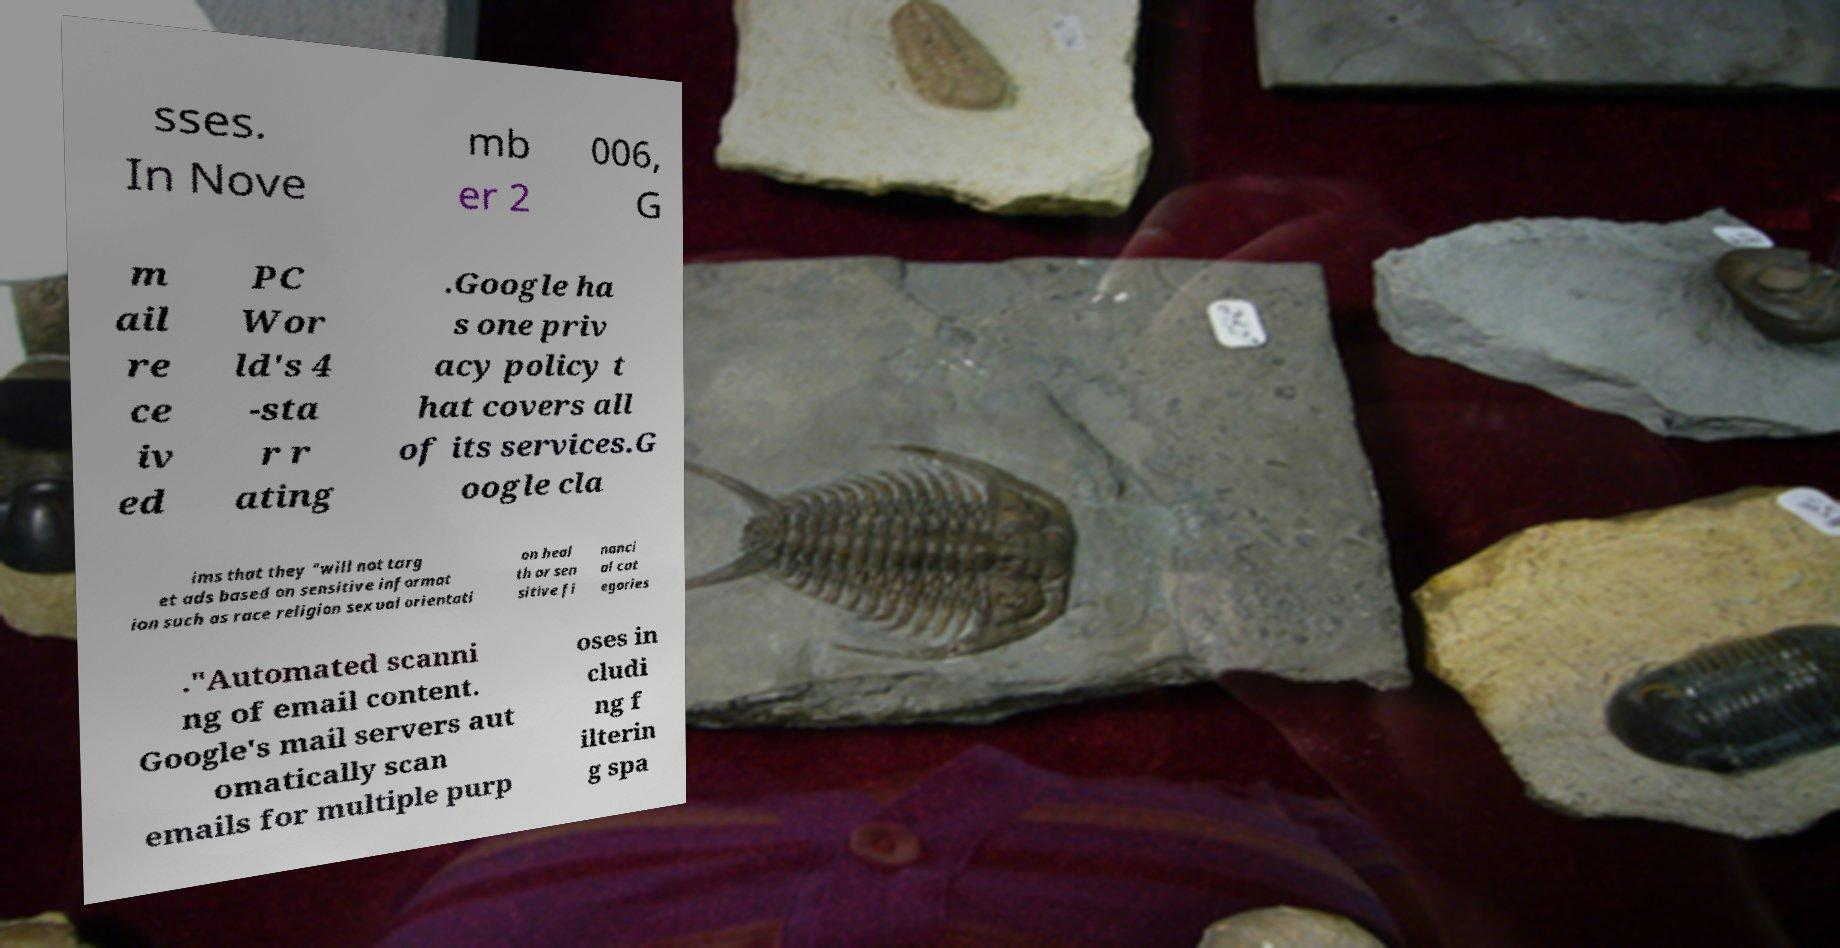Can you accurately transcribe the text from the provided image for me? sses. In Nove mb er 2 006, G m ail re ce iv ed PC Wor ld's 4 -sta r r ating .Google ha s one priv acy policy t hat covers all of its services.G oogle cla ims that they "will not targ et ads based on sensitive informat ion such as race religion sexual orientati on heal th or sen sitive fi nanci al cat egories ."Automated scanni ng of email content. Google's mail servers aut omatically scan emails for multiple purp oses in cludi ng f ilterin g spa 